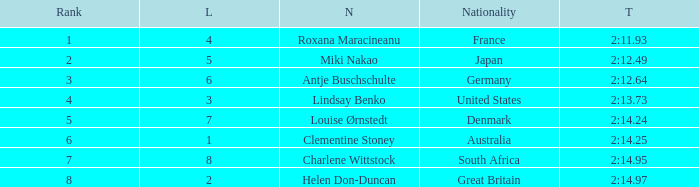What is the number of lane with a rank more than 2 for louise ørnstedt? 1.0. 